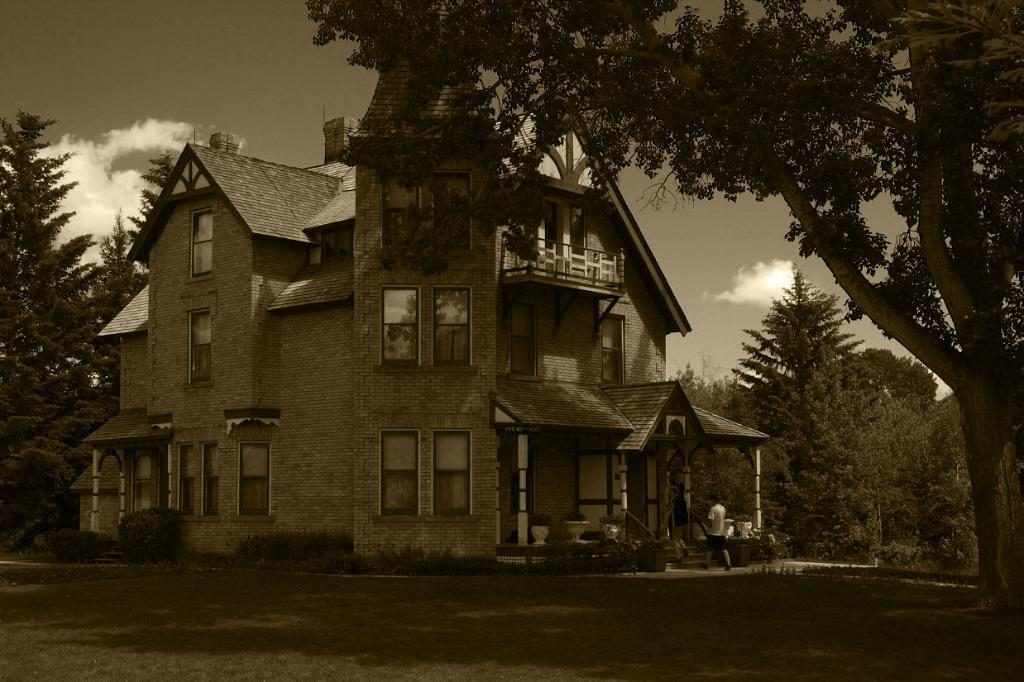What type of vegetation is in the foreground of the image? There is grass in the foreground of the image. What structure is located in the middle of the image? There is a house in the middle of the image. What other object is located in the middle of the image? There is a tree in the middle of the image. Who or what else is present in the middle of the image? There is a person in the middle of the image. What is visible at the top of the image? The sky is visible at the top of the image. What type of cord is being used by the person in the image? There is no cord visible in the image; the person is not using any cord. What is the person's level of wealth in the image? There is no information about the person's wealth in the image. 